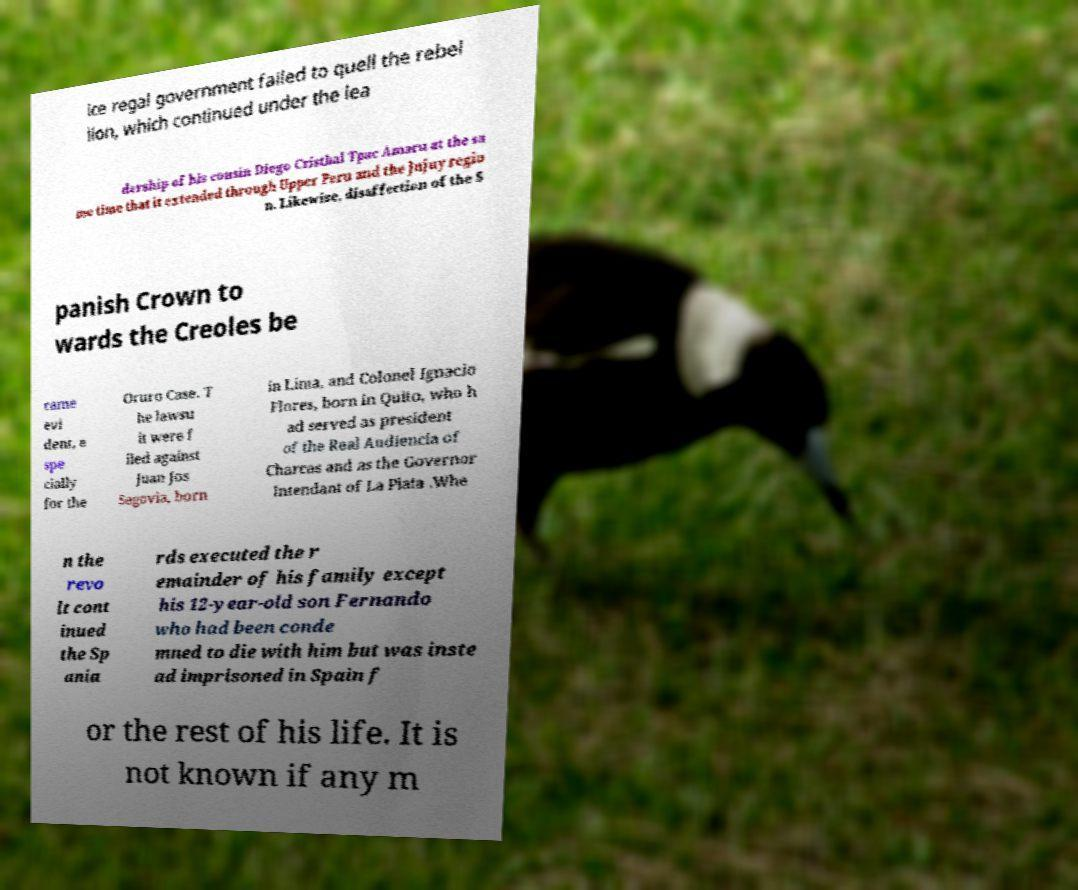For documentation purposes, I need the text within this image transcribed. Could you provide that? ice regal government failed to quell the rebel lion, which continued under the lea dership of his cousin Diego Cristbal Tpac Amaru at the sa me time that it extended through Upper Peru and the Jujuy regio n. Likewise, disaffection of the S panish Crown to wards the Creoles be came evi dent, e spe cially for the Oruro Case. T he lawsu it were f iled against Juan Jos Segovia, born in Lima, and Colonel Ignacio Flores, born in Quito, who h ad served as president of the Real Audiencia of Charcas and as the Governor Intendant of La Plata .Whe n the revo lt cont inued the Sp ania rds executed the r emainder of his family except his 12-year-old son Fernando who had been conde mned to die with him but was inste ad imprisoned in Spain f or the rest of his life. It is not known if any m 